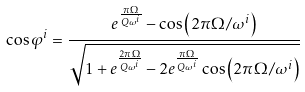<formula> <loc_0><loc_0><loc_500><loc_500>\cos \varphi ^ { i } = \frac { e ^ { \frac { \pi \Omega } { Q \omega ^ { i } } } - \cos \left ( 2 \pi \Omega / \omega ^ { i } \right ) } { \sqrt { 1 + e ^ { \frac { 2 \pi \Omega } { Q \omega ^ { i } } } - 2 e ^ { \frac { \pi \Omega } { Q \omega ^ { i } } } \cos \left ( 2 \pi \Omega / \omega ^ { i } \right ) } }</formula> 